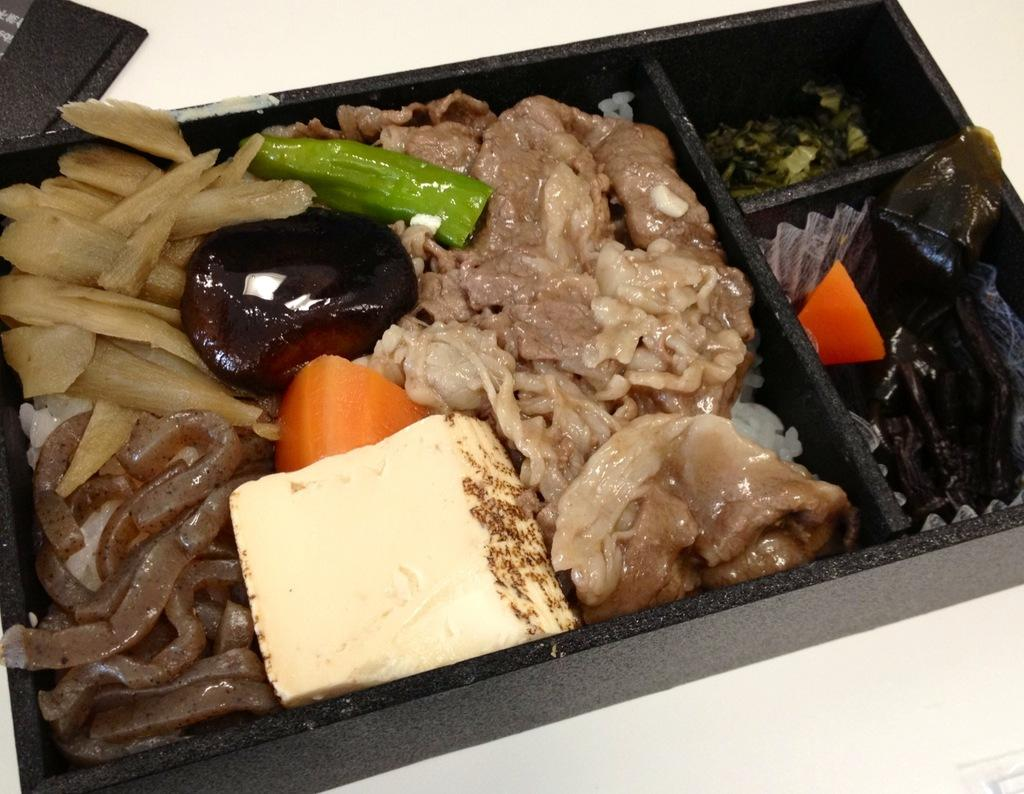What is the color of the tray containing food items in the image? The tray is black. What is the color of the surface on which the tray is placed? The surface is white. Can you describe the food items in the tray? Unfortunately, the facts provided do not specify the type of food items in the tray. What object can be seen at the top of the image? The facts provided do not specify the object at the top of the image. How much sand is visible in the image? There is no sand present in the image. What type of cabbage is being used as a brake in the image? There is no cabbage or brake present in the image. 